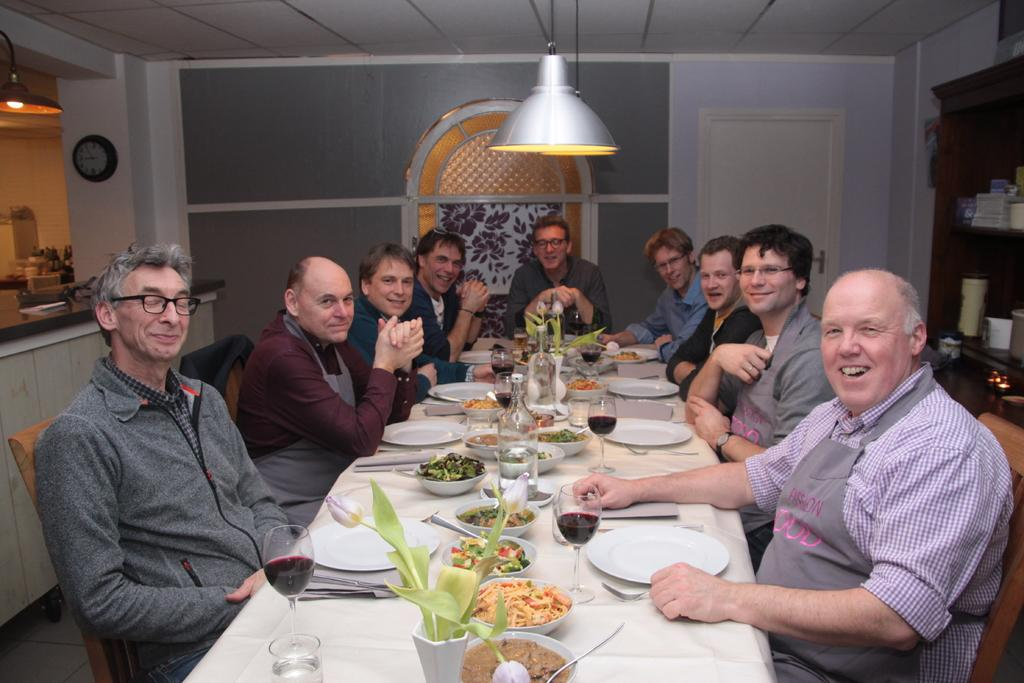What are the people in the image doing? The people in the image are sitting on chairs. What is in front of the people? There is a table in front of the people. What can be found on the table? There is food in a bowl and wine glasses on the table. What type of print can be seen on the wine glasses in the image? There is no information about the print on the wine glasses in the image. 